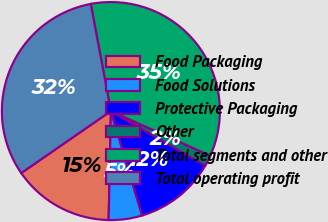Convert chart to OTSL. <chart><loc_0><loc_0><loc_500><loc_500><pie_chart><fcel>Food Packaging<fcel>Food Solutions<fcel>Protective Packaging<fcel>Other<fcel>Total segments and other<fcel>Total operating profit<nl><fcel>15.04%<fcel>4.96%<fcel>12.03%<fcel>1.61%<fcel>34.68%<fcel>31.67%<nl></chart> 